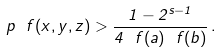<formula> <loc_0><loc_0><loc_500><loc_500>p _ { \ } f ( x , y , z ) > \frac { 1 - 2 ^ { s - 1 } } { 4 \ f ( a ) \ f ( b ) } \, .</formula> 